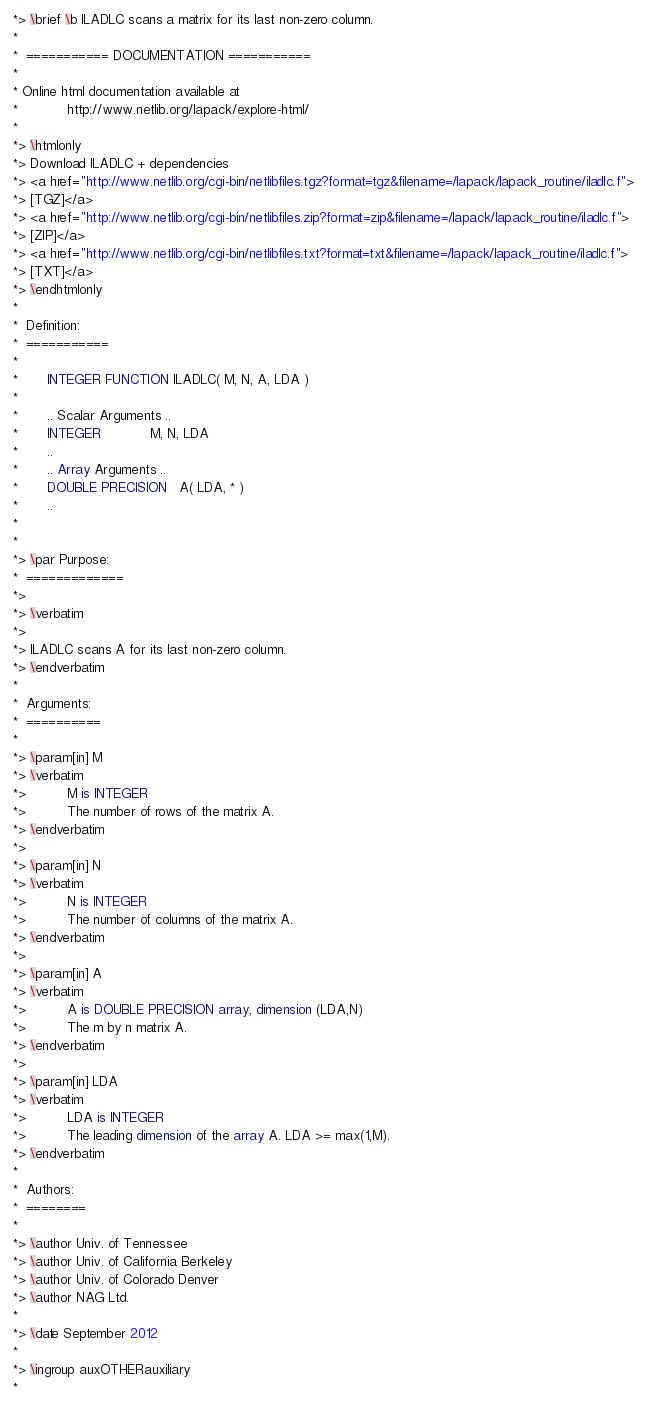<code> <loc_0><loc_0><loc_500><loc_500><_FORTRAN_>*> \brief \b ILADLC scans a matrix for its last non-zero column.
*
*  =========== DOCUMENTATION ===========
*
* Online html documentation available at
*            http://www.netlib.org/lapack/explore-html/
*
*> \htmlonly
*> Download ILADLC + dependencies
*> <a href="http://www.netlib.org/cgi-bin/netlibfiles.tgz?format=tgz&filename=/lapack/lapack_routine/iladlc.f">
*> [TGZ]</a>
*> <a href="http://www.netlib.org/cgi-bin/netlibfiles.zip?format=zip&filename=/lapack/lapack_routine/iladlc.f">
*> [ZIP]</a>
*> <a href="http://www.netlib.org/cgi-bin/netlibfiles.txt?format=txt&filename=/lapack/lapack_routine/iladlc.f">
*> [TXT]</a>
*> \endhtmlonly
*
*  Definition:
*  ===========
*
*       INTEGER FUNCTION ILADLC( M, N, A, LDA )
*
*       .. Scalar Arguments ..
*       INTEGER            M, N, LDA
*       ..
*       .. Array Arguments ..
*       DOUBLE PRECISION   A( LDA, * )
*       ..
*
*
*> \par Purpose:
*  =============
*>
*> \verbatim
*>
*> ILADLC scans A for its last non-zero column.
*> \endverbatim
*
*  Arguments:
*  ==========
*
*> \param[in] M
*> \verbatim
*>          M is INTEGER
*>          The number of rows of the matrix A.
*> \endverbatim
*>
*> \param[in] N
*> \verbatim
*>          N is INTEGER
*>          The number of columns of the matrix A.
*> \endverbatim
*>
*> \param[in] A
*> \verbatim
*>          A is DOUBLE PRECISION array, dimension (LDA,N)
*>          The m by n matrix A.
*> \endverbatim
*>
*> \param[in] LDA
*> \verbatim
*>          LDA is INTEGER
*>          The leading dimension of the array A. LDA >= max(1,M).
*> \endverbatim
*
*  Authors:
*  ========
*
*> \author Univ. of Tennessee
*> \author Univ. of California Berkeley
*> \author Univ. of Colorado Denver
*> \author NAG Ltd.
*
*> \date September 2012
*
*> \ingroup auxOTHERauxiliary
*</code> 